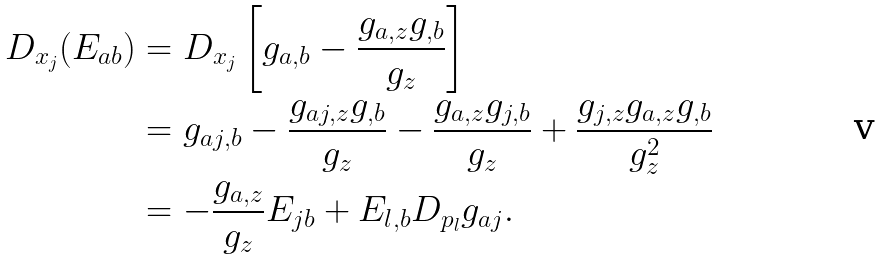<formula> <loc_0><loc_0><loc_500><loc_500>D _ { x _ { j } } ( E _ { a b } ) & = D _ { x _ { j } } \left [ g _ { a , b } - \frac { g _ { a , z } g _ { , b } } { g _ { z } } \right ] \\ & = g _ { a j , b } - \frac { g _ { a j , z } g _ { , b } } { g _ { z } } - \frac { g _ { a , z } g _ { j , b } } { g _ { z } } + \frac { g _ { j , z } g _ { a , z } g _ { , b } } { g _ { z } ^ { 2 } } \\ & = - \frac { g _ { a , z } } { g _ { z } } E _ { j b } + E _ { l , b } D _ { p _ { l } } g _ { a j } .</formula> 